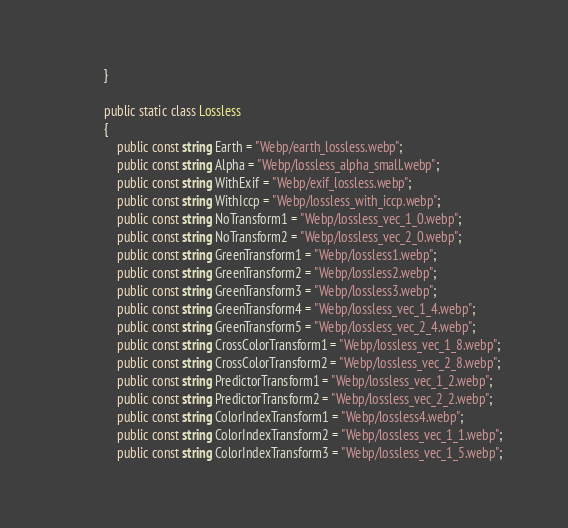Convert code to text. <code><loc_0><loc_0><loc_500><loc_500><_C#_>            }

            public static class Lossless
            {
                public const string Earth = "Webp/earth_lossless.webp";
                public const string Alpha = "Webp/lossless_alpha_small.webp";
                public const string WithExif = "Webp/exif_lossless.webp";
                public const string WithIccp = "Webp/lossless_with_iccp.webp";
                public const string NoTransform1 = "Webp/lossless_vec_1_0.webp";
                public const string NoTransform2 = "Webp/lossless_vec_2_0.webp";
                public const string GreenTransform1 = "Webp/lossless1.webp";
                public const string GreenTransform2 = "Webp/lossless2.webp";
                public const string GreenTransform3 = "Webp/lossless3.webp";
                public const string GreenTransform4 = "Webp/lossless_vec_1_4.webp";
                public const string GreenTransform5 = "Webp/lossless_vec_2_4.webp";
                public const string CrossColorTransform1 = "Webp/lossless_vec_1_8.webp";
                public const string CrossColorTransform2 = "Webp/lossless_vec_2_8.webp";
                public const string PredictorTransform1 = "Webp/lossless_vec_1_2.webp";
                public const string PredictorTransform2 = "Webp/lossless_vec_2_2.webp";
                public const string ColorIndexTransform1 = "Webp/lossless4.webp";
                public const string ColorIndexTransform2 = "Webp/lossless_vec_1_1.webp";
                public const string ColorIndexTransform3 = "Webp/lossless_vec_1_5.webp";</code> 